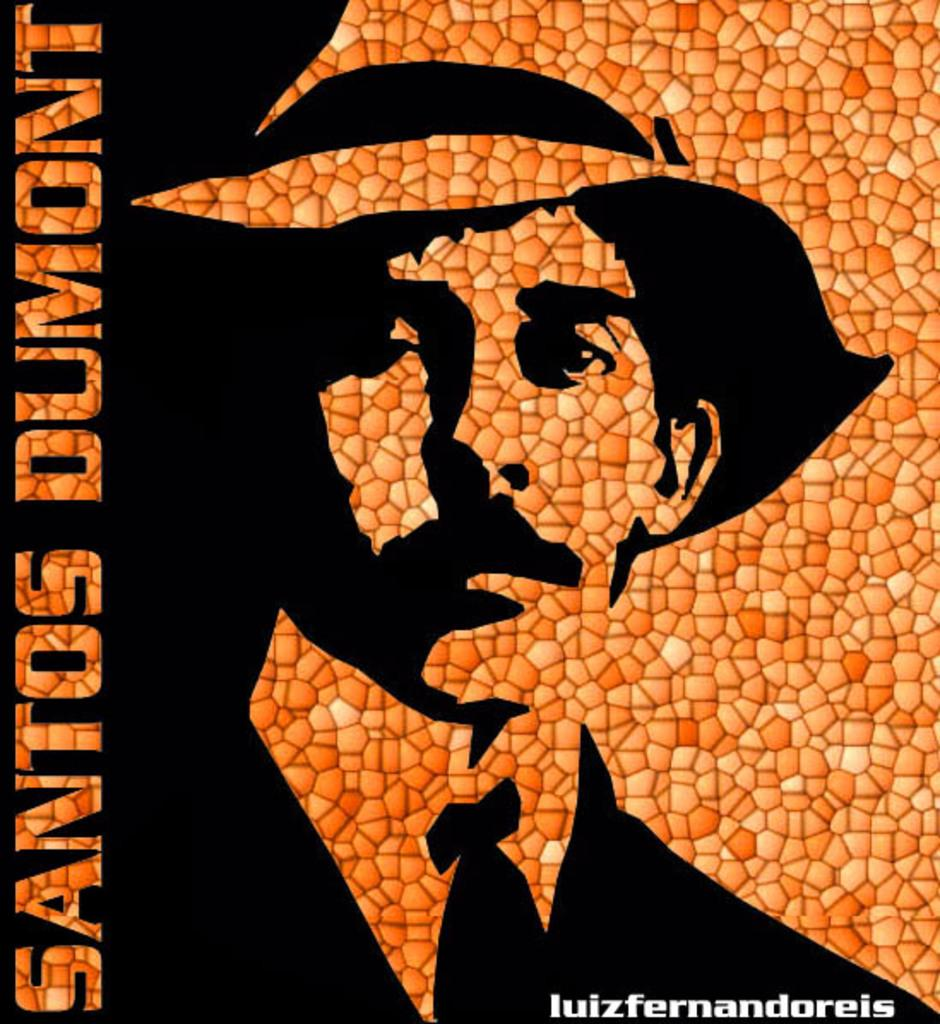<image>
Give a short and clear explanation of the subsequent image. A poster with a man with a mustache, wearing a hat and tie and has the name Santos Dumon on it. 